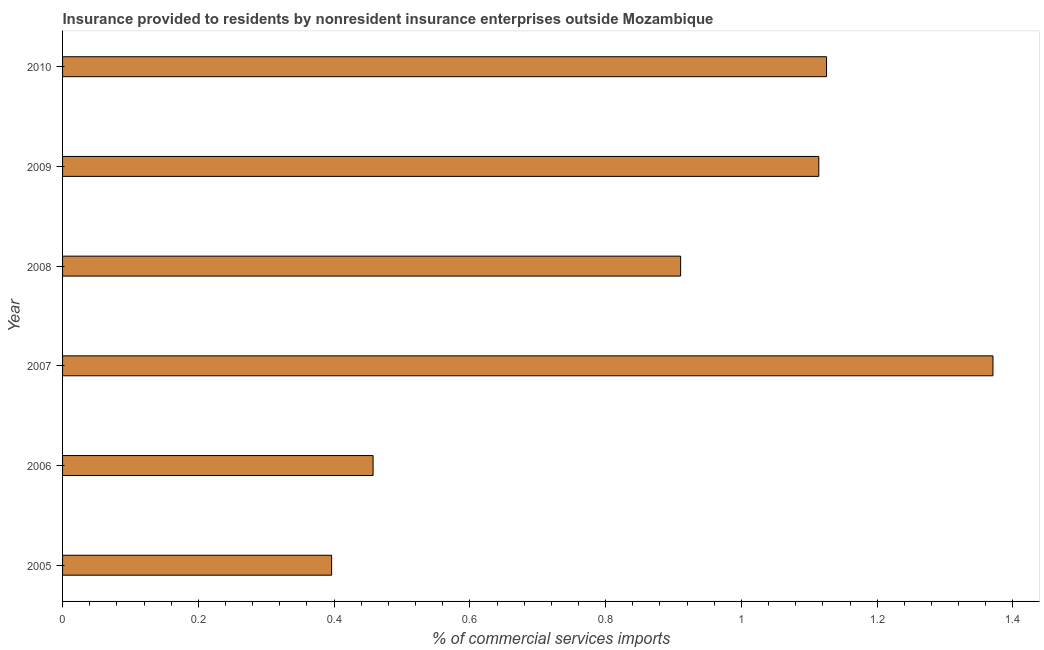What is the title of the graph?
Your answer should be very brief. Insurance provided to residents by nonresident insurance enterprises outside Mozambique. What is the label or title of the X-axis?
Your answer should be compact. % of commercial services imports. What is the insurance provided by non-residents in 2010?
Provide a succinct answer. 1.13. Across all years, what is the maximum insurance provided by non-residents?
Offer a very short reply. 1.37. Across all years, what is the minimum insurance provided by non-residents?
Make the answer very short. 0.4. In which year was the insurance provided by non-residents maximum?
Your response must be concise. 2007. In which year was the insurance provided by non-residents minimum?
Provide a short and direct response. 2005. What is the sum of the insurance provided by non-residents?
Your response must be concise. 5.37. What is the difference between the insurance provided by non-residents in 2006 and 2009?
Provide a short and direct response. -0.66. What is the average insurance provided by non-residents per year?
Your response must be concise. 0.9. What is the median insurance provided by non-residents?
Your response must be concise. 1.01. In how many years, is the insurance provided by non-residents greater than 0.76 %?
Your response must be concise. 4. Do a majority of the years between 2008 and 2010 (inclusive) have insurance provided by non-residents greater than 1.24 %?
Give a very brief answer. No. What is the ratio of the insurance provided by non-residents in 2005 to that in 2007?
Your response must be concise. 0.29. Is the insurance provided by non-residents in 2007 less than that in 2009?
Your answer should be compact. No. Is the difference between the insurance provided by non-residents in 2007 and 2010 greater than the difference between any two years?
Your answer should be compact. No. What is the difference between the highest and the second highest insurance provided by non-residents?
Your response must be concise. 0.24. Is the sum of the insurance provided by non-residents in 2008 and 2009 greater than the maximum insurance provided by non-residents across all years?
Provide a short and direct response. Yes. In how many years, is the insurance provided by non-residents greater than the average insurance provided by non-residents taken over all years?
Make the answer very short. 4. What is the difference between two consecutive major ticks on the X-axis?
Provide a short and direct response. 0.2. Are the values on the major ticks of X-axis written in scientific E-notation?
Make the answer very short. No. What is the % of commercial services imports in 2005?
Your response must be concise. 0.4. What is the % of commercial services imports in 2006?
Your response must be concise. 0.46. What is the % of commercial services imports in 2007?
Provide a short and direct response. 1.37. What is the % of commercial services imports of 2008?
Your answer should be compact. 0.91. What is the % of commercial services imports of 2009?
Your answer should be compact. 1.11. What is the % of commercial services imports of 2010?
Keep it short and to the point. 1.13. What is the difference between the % of commercial services imports in 2005 and 2006?
Make the answer very short. -0.06. What is the difference between the % of commercial services imports in 2005 and 2007?
Offer a terse response. -0.97. What is the difference between the % of commercial services imports in 2005 and 2008?
Offer a very short reply. -0.51. What is the difference between the % of commercial services imports in 2005 and 2009?
Ensure brevity in your answer.  -0.72. What is the difference between the % of commercial services imports in 2005 and 2010?
Keep it short and to the point. -0.73. What is the difference between the % of commercial services imports in 2006 and 2007?
Offer a terse response. -0.91. What is the difference between the % of commercial services imports in 2006 and 2008?
Keep it short and to the point. -0.45. What is the difference between the % of commercial services imports in 2006 and 2009?
Offer a terse response. -0.66. What is the difference between the % of commercial services imports in 2006 and 2010?
Provide a short and direct response. -0.67. What is the difference between the % of commercial services imports in 2007 and 2008?
Give a very brief answer. 0.46. What is the difference between the % of commercial services imports in 2007 and 2009?
Provide a succinct answer. 0.26. What is the difference between the % of commercial services imports in 2007 and 2010?
Your response must be concise. 0.25. What is the difference between the % of commercial services imports in 2008 and 2009?
Give a very brief answer. -0.2. What is the difference between the % of commercial services imports in 2008 and 2010?
Make the answer very short. -0.21. What is the difference between the % of commercial services imports in 2009 and 2010?
Your response must be concise. -0.01. What is the ratio of the % of commercial services imports in 2005 to that in 2006?
Your answer should be compact. 0.87. What is the ratio of the % of commercial services imports in 2005 to that in 2007?
Your answer should be compact. 0.29. What is the ratio of the % of commercial services imports in 2005 to that in 2008?
Keep it short and to the point. 0.43. What is the ratio of the % of commercial services imports in 2005 to that in 2009?
Offer a terse response. 0.36. What is the ratio of the % of commercial services imports in 2005 to that in 2010?
Make the answer very short. 0.35. What is the ratio of the % of commercial services imports in 2006 to that in 2007?
Offer a terse response. 0.33. What is the ratio of the % of commercial services imports in 2006 to that in 2008?
Your answer should be very brief. 0.5. What is the ratio of the % of commercial services imports in 2006 to that in 2009?
Provide a succinct answer. 0.41. What is the ratio of the % of commercial services imports in 2006 to that in 2010?
Offer a very short reply. 0.41. What is the ratio of the % of commercial services imports in 2007 to that in 2008?
Your answer should be compact. 1.5. What is the ratio of the % of commercial services imports in 2007 to that in 2009?
Offer a terse response. 1.23. What is the ratio of the % of commercial services imports in 2007 to that in 2010?
Provide a short and direct response. 1.22. What is the ratio of the % of commercial services imports in 2008 to that in 2009?
Ensure brevity in your answer.  0.82. What is the ratio of the % of commercial services imports in 2008 to that in 2010?
Your answer should be compact. 0.81. 